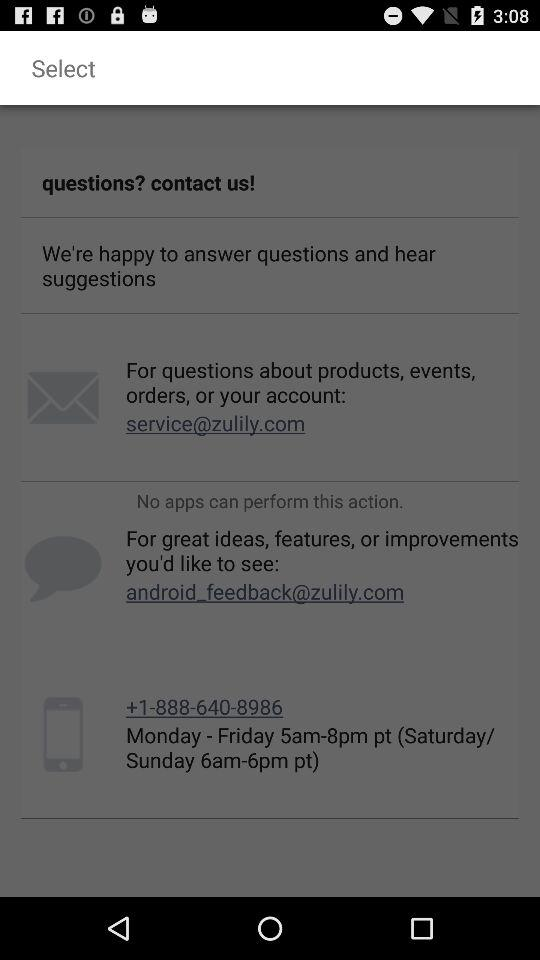What is the daily time to connect through the contact number for queries? The daily time to connect through the contact number for queries is Monday to Friday, 5 a.m. to 8 p.m. Pacific Time; and Saturday and Sunday, 6 a.m. to 6 p.m. Pacific Time. 